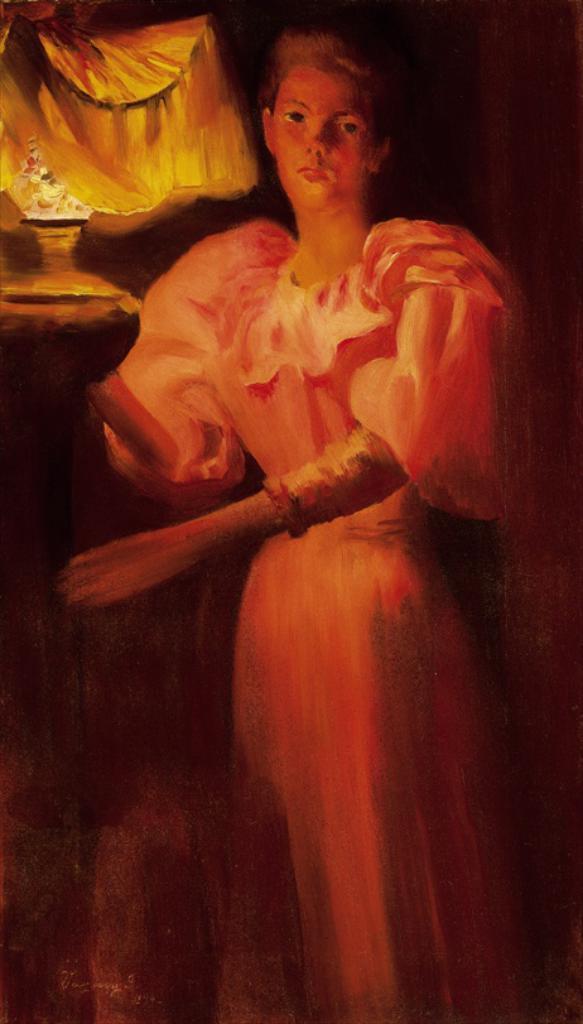Please provide a concise description of this image. This is a painting picture. Here we can see one woman standing and this is a pot. 